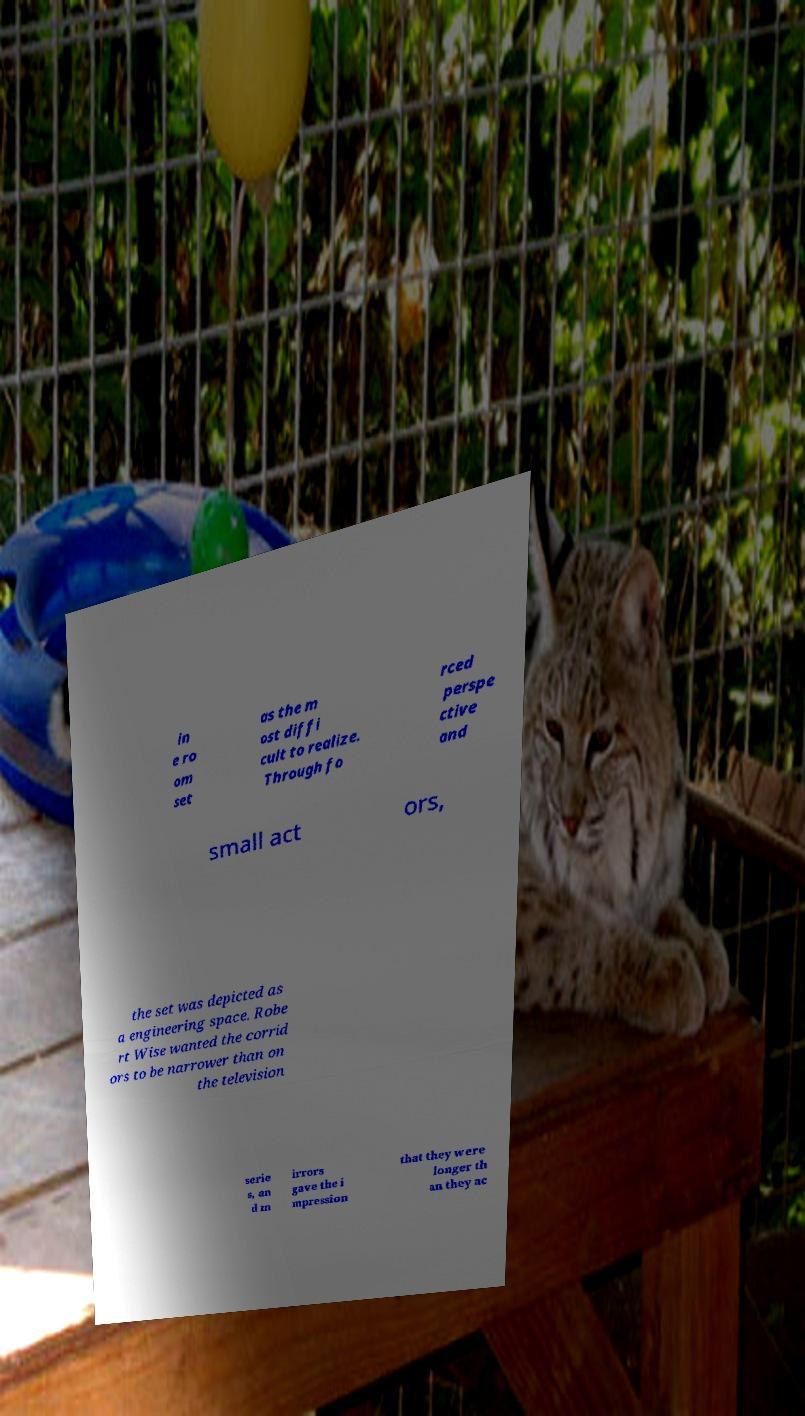Can you accurately transcribe the text from the provided image for me? in e ro om set as the m ost diffi cult to realize. Through fo rced perspe ctive and small act ors, the set was depicted as a engineering space. Robe rt Wise wanted the corrid ors to be narrower than on the television serie s, an d m irrors gave the i mpression that they were longer th an they ac 